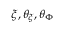Convert formula to latex. <formula><loc_0><loc_0><loc_500><loc_500>\xi , \theta _ { \xi } , \theta _ { \Phi }</formula> 